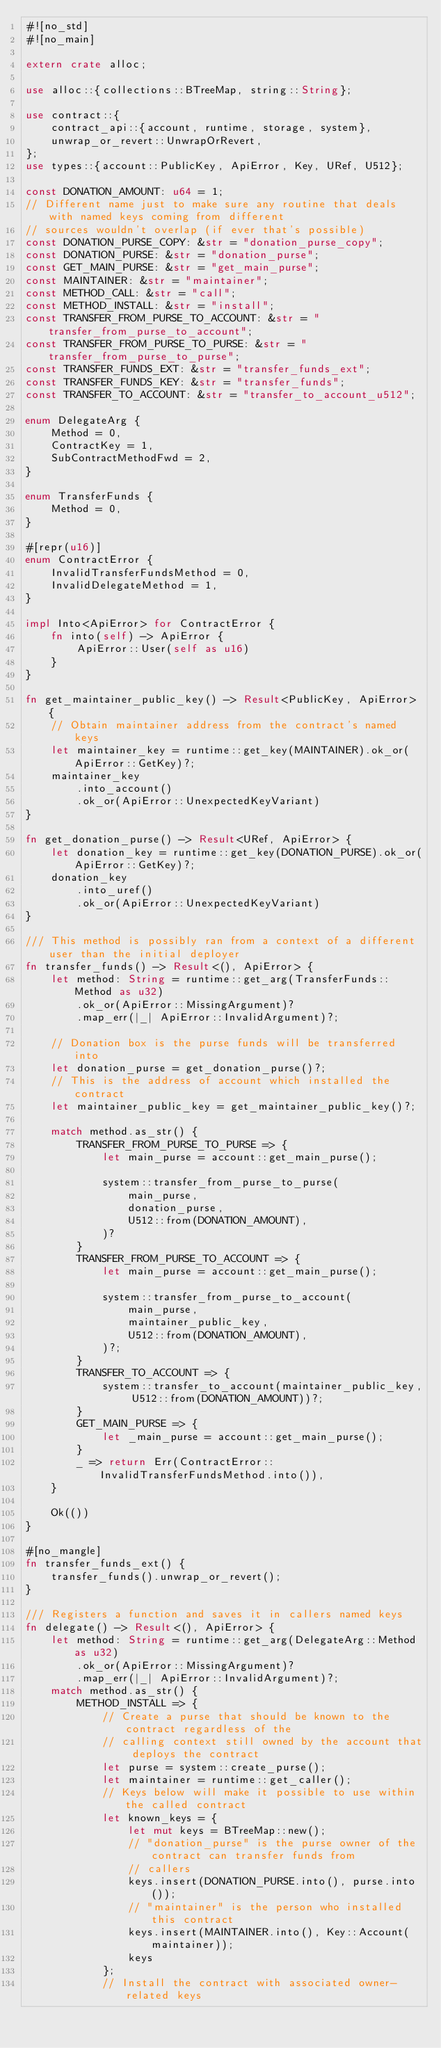Convert code to text. <code><loc_0><loc_0><loc_500><loc_500><_Rust_>#![no_std]
#![no_main]

extern crate alloc;

use alloc::{collections::BTreeMap, string::String};

use contract::{
    contract_api::{account, runtime, storage, system},
    unwrap_or_revert::UnwrapOrRevert,
};
use types::{account::PublicKey, ApiError, Key, URef, U512};

const DONATION_AMOUNT: u64 = 1;
// Different name just to make sure any routine that deals with named keys coming from different
// sources wouldn't overlap (if ever that's possible)
const DONATION_PURSE_COPY: &str = "donation_purse_copy";
const DONATION_PURSE: &str = "donation_purse";
const GET_MAIN_PURSE: &str = "get_main_purse";
const MAINTAINER: &str = "maintainer";
const METHOD_CALL: &str = "call";
const METHOD_INSTALL: &str = "install";
const TRANSFER_FROM_PURSE_TO_ACCOUNT: &str = "transfer_from_purse_to_account";
const TRANSFER_FROM_PURSE_TO_PURSE: &str = "transfer_from_purse_to_purse";
const TRANSFER_FUNDS_EXT: &str = "transfer_funds_ext";
const TRANSFER_FUNDS_KEY: &str = "transfer_funds";
const TRANSFER_TO_ACCOUNT: &str = "transfer_to_account_u512";

enum DelegateArg {
    Method = 0,
    ContractKey = 1,
    SubContractMethodFwd = 2,
}

enum TransferFunds {
    Method = 0,
}

#[repr(u16)]
enum ContractError {
    InvalidTransferFundsMethod = 0,
    InvalidDelegateMethod = 1,
}

impl Into<ApiError> for ContractError {
    fn into(self) -> ApiError {
        ApiError::User(self as u16)
    }
}

fn get_maintainer_public_key() -> Result<PublicKey, ApiError> {
    // Obtain maintainer address from the contract's named keys
    let maintainer_key = runtime::get_key(MAINTAINER).ok_or(ApiError::GetKey)?;
    maintainer_key
        .into_account()
        .ok_or(ApiError::UnexpectedKeyVariant)
}

fn get_donation_purse() -> Result<URef, ApiError> {
    let donation_key = runtime::get_key(DONATION_PURSE).ok_or(ApiError::GetKey)?;
    donation_key
        .into_uref()
        .ok_or(ApiError::UnexpectedKeyVariant)
}

/// This method is possibly ran from a context of a different user than the initial deployer
fn transfer_funds() -> Result<(), ApiError> {
    let method: String = runtime::get_arg(TransferFunds::Method as u32)
        .ok_or(ApiError::MissingArgument)?
        .map_err(|_| ApiError::InvalidArgument)?;

    // Donation box is the purse funds will be transferred into
    let donation_purse = get_donation_purse()?;
    // This is the address of account which installed the contract
    let maintainer_public_key = get_maintainer_public_key()?;

    match method.as_str() {
        TRANSFER_FROM_PURSE_TO_PURSE => {
            let main_purse = account::get_main_purse();

            system::transfer_from_purse_to_purse(
                main_purse,
                donation_purse,
                U512::from(DONATION_AMOUNT),
            )?
        }
        TRANSFER_FROM_PURSE_TO_ACCOUNT => {
            let main_purse = account::get_main_purse();

            system::transfer_from_purse_to_account(
                main_purse,
                maintainer_public_key,
                U512::from(DONATION_AMOUNT),
            )?;
        }
        TRANSFER_TO_ACCOUNT => {
            system::transfer_to_account(maintainer_public_key, U512::from(DONATION_AMOUNT))?;
        }
        GET_MAIN_PURSE => {
            let _main_purse = account::get_main_purse();
        }
        _ => return Err(ContractError::InvalidTransferFundsMethod.into()),
    }

    Ok(())
}

#[no_mangle]
fn transfer_funds_ext() {
    transfer_funds().unwrap_or_revert();
}

/// Registers a function and saves it in callers named keys
fn delegate() -> Result<(), ApiError> {
    let method: String = runtime::get_arg(DelegateArg::Method as u32)
        .ok_or(ApiError::MissingArgument)?
        .map_err(|_| ApiError::InvalidArgument)?;
    match method.as_str() {
        METHOD_INSTALL => {
            // Create a purse that should be known to the contract regardless of the
            // calling context still owned by the account that deploys the contract
            let purse = system::create_purse();
            let maintainer = runtime::get_caller();
            // Keys below will make it possible to use within the called contract
            let known_keys = {
                let mut keys = BTreeMap::new();
                // "donation_purse" is the purse owner of the contract can transfer funds from
                // callers
                keys.insert(DONATION_PURSE.into(), purse.into());
                // "maintainer" is the person who installed this contract
                keys.insert(MAINTAINER.into(), Key::Account(maintainer));
                keys
            };
            // Install the contract with associated owner-related keys</code> 